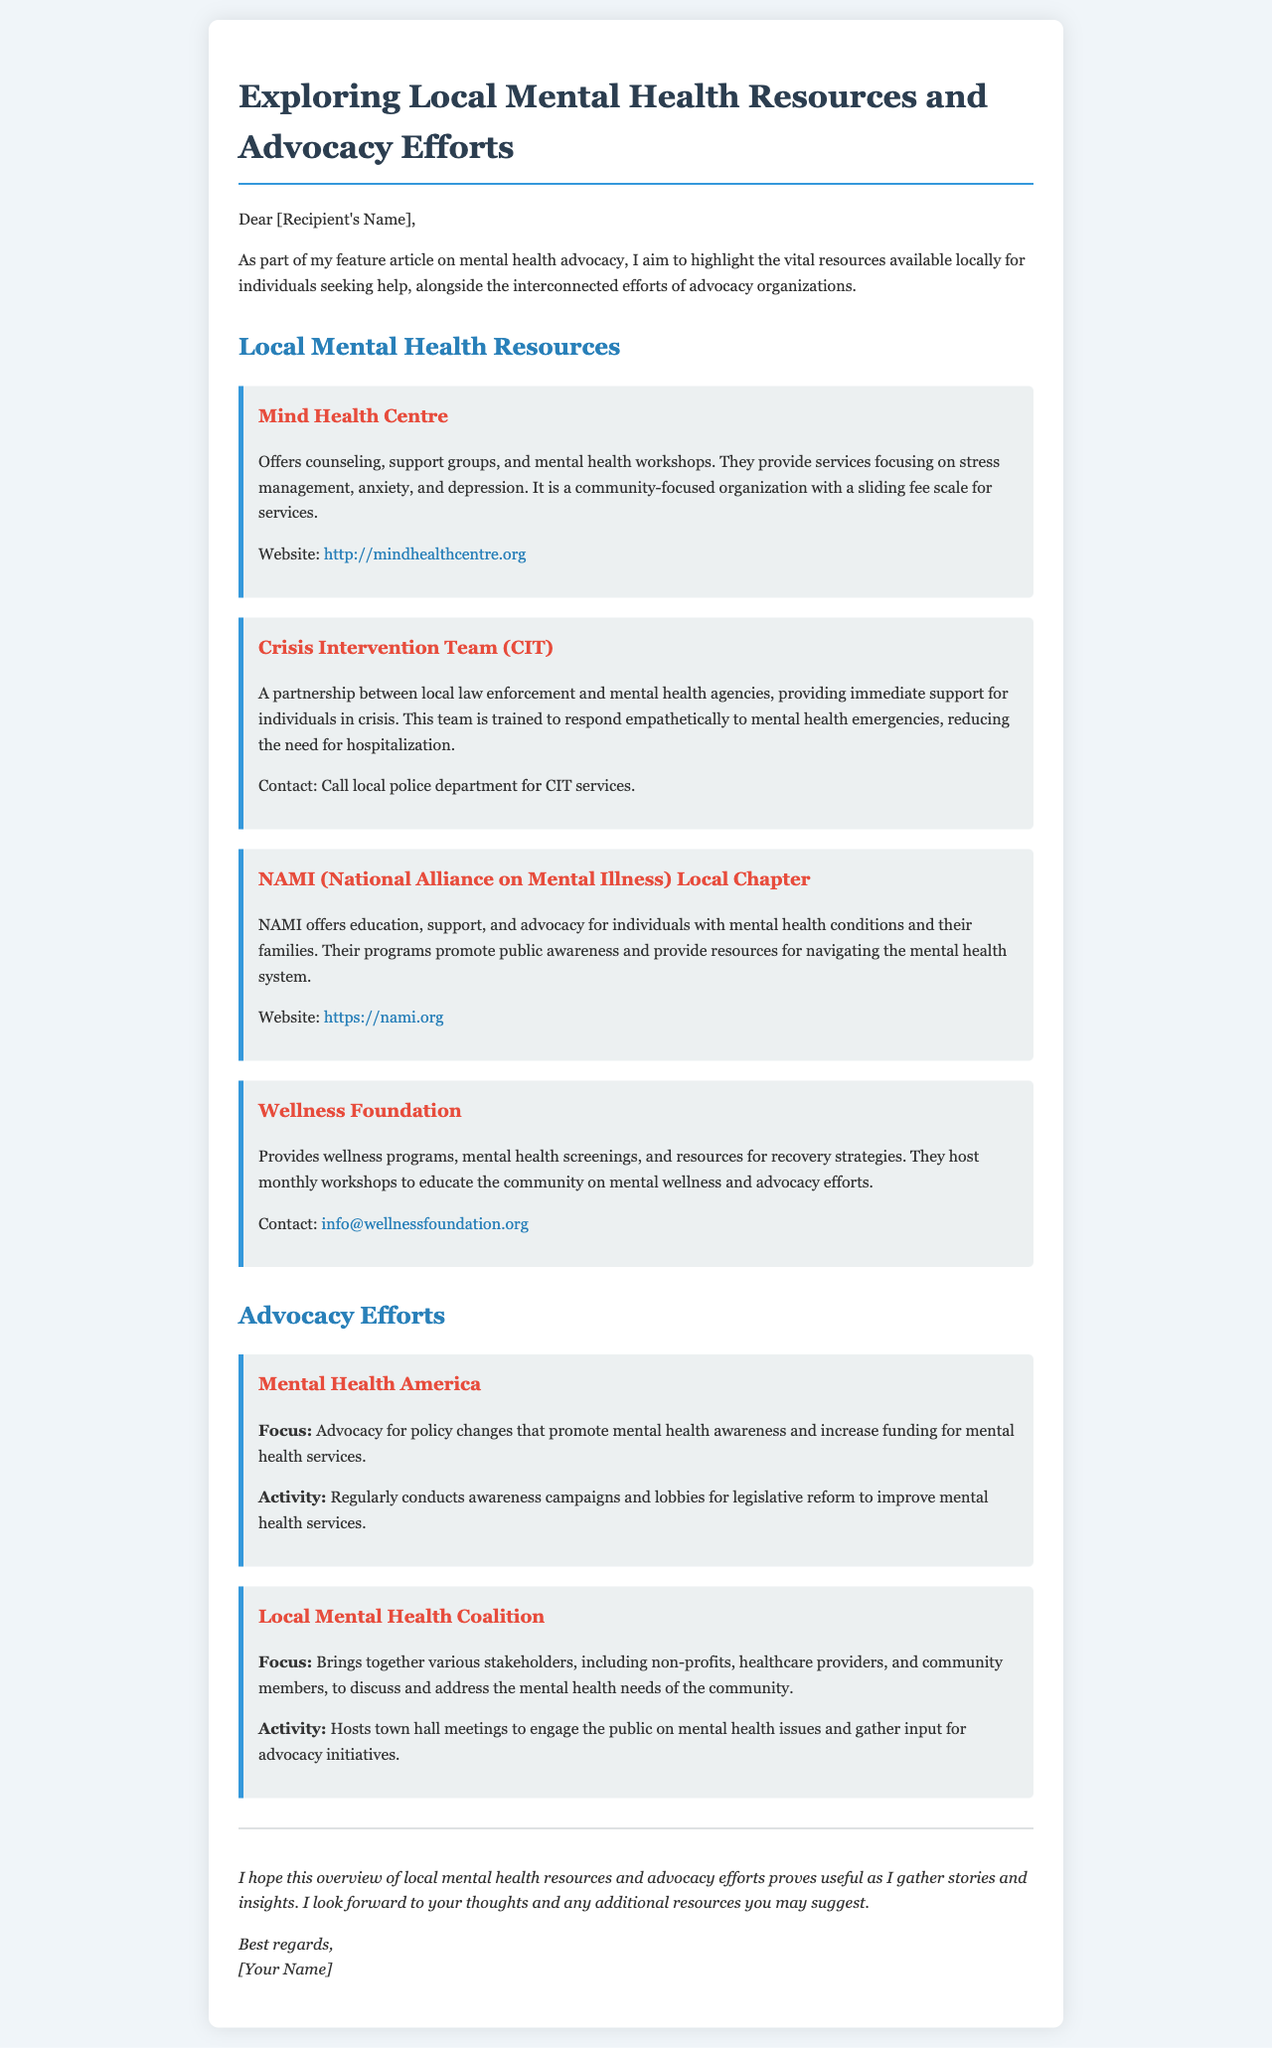What organization offers counseling and workshops? The document states that the Mind Health Centre offers counseling, support groups, and mental health workshops.
Answer: Mind Health Centre What is the focus of the Local Mental Health Coalition? The document indicates that the focus is to bring together various stakeholders to discuss and address the mental health needs of the community.
Answer: Discuss and address community needs How can one reach the Wellness Foundation? The document provides an email address for inquiries regarding the Wellness Foundation.
Answer: info@wellnessfoundation.org What is the purpose of the Crisis Intervention Team (CIT)? The document explains that CIT provides immediate support for individuals in crisis and is trained to respond empathetically to mental health emergencies.
Answer: Immediate support in crises Which organization conducts awareness campaigns for legislative reform? According to the document, Mental Health America conducts awareness campaigns and lobbies for legislative reform.
Answer: Mental Health America What type of events does NAMI host for public awareness? The document notes that NAMI offers education, support, and advocacy, which includes public awareness programs.
Answer: Education and support programs 